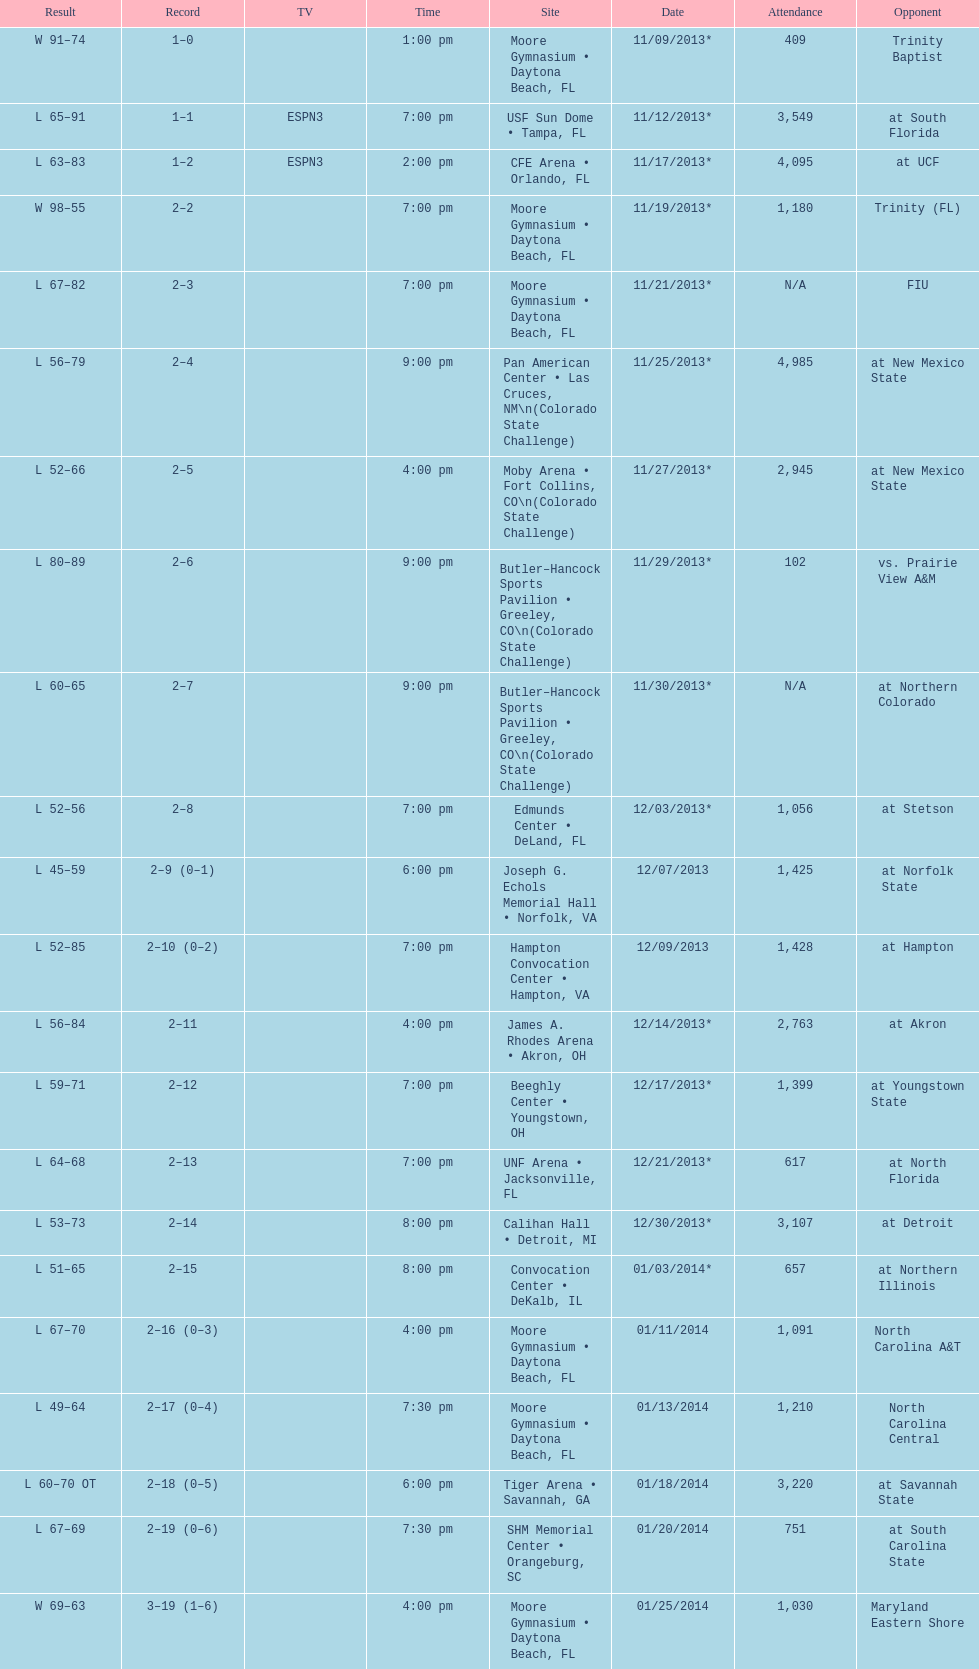How many games had more than 1,500 in attendance? 12. 